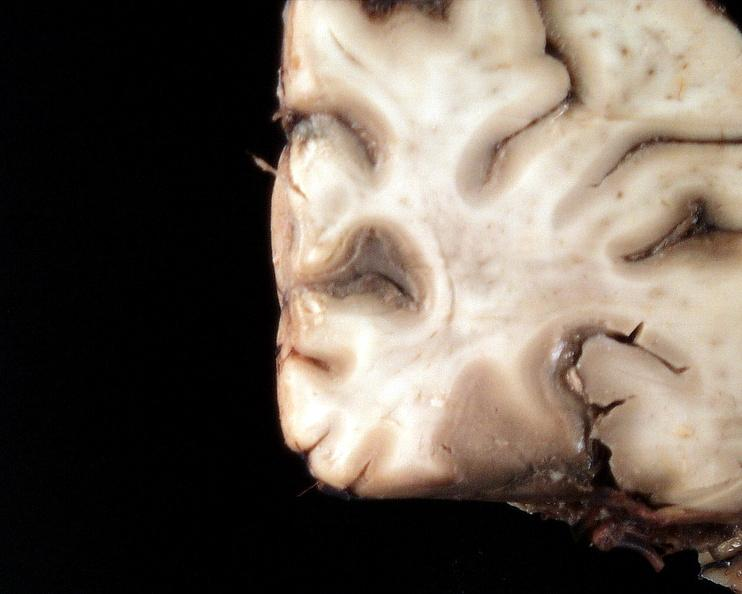what does this image show?
Answer the question using a single word or phrase. Brain 